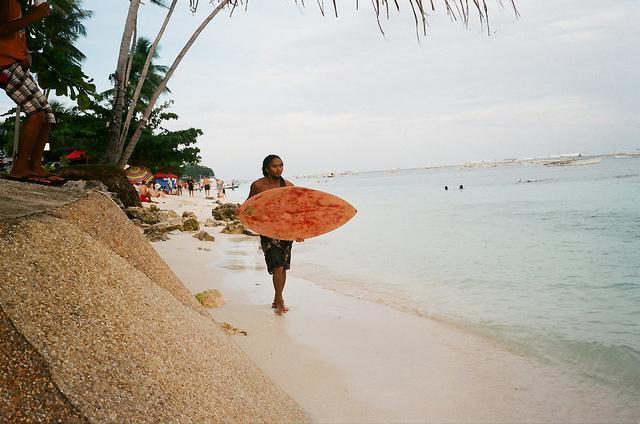Why is the man on the beach holding the object?
Choose the right answer from the provided options to respond to the question.
Options: To dance, to ski, to surf, to swim. To surf. 